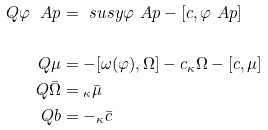Convert formula to latex. <formula><loc_0><loc_0><loc_500><loc_500>Q \varphi ^ { \ } A p & = \ s u s y \varphi ^ { \ } A p - [ c , \varphi ^ { \ } A p ] \\ \\ Q \mu & = - [ \omega ( \varphi ) , \Omega ] - \L c _ { \kappa } \Omega - [ c , \mu ] \\ Q \bar { \Omega } & = \L _ { \kappa } \bar { \mu } \\ Q b & = - \L _ { \kappa } \bar { c }</formula> 